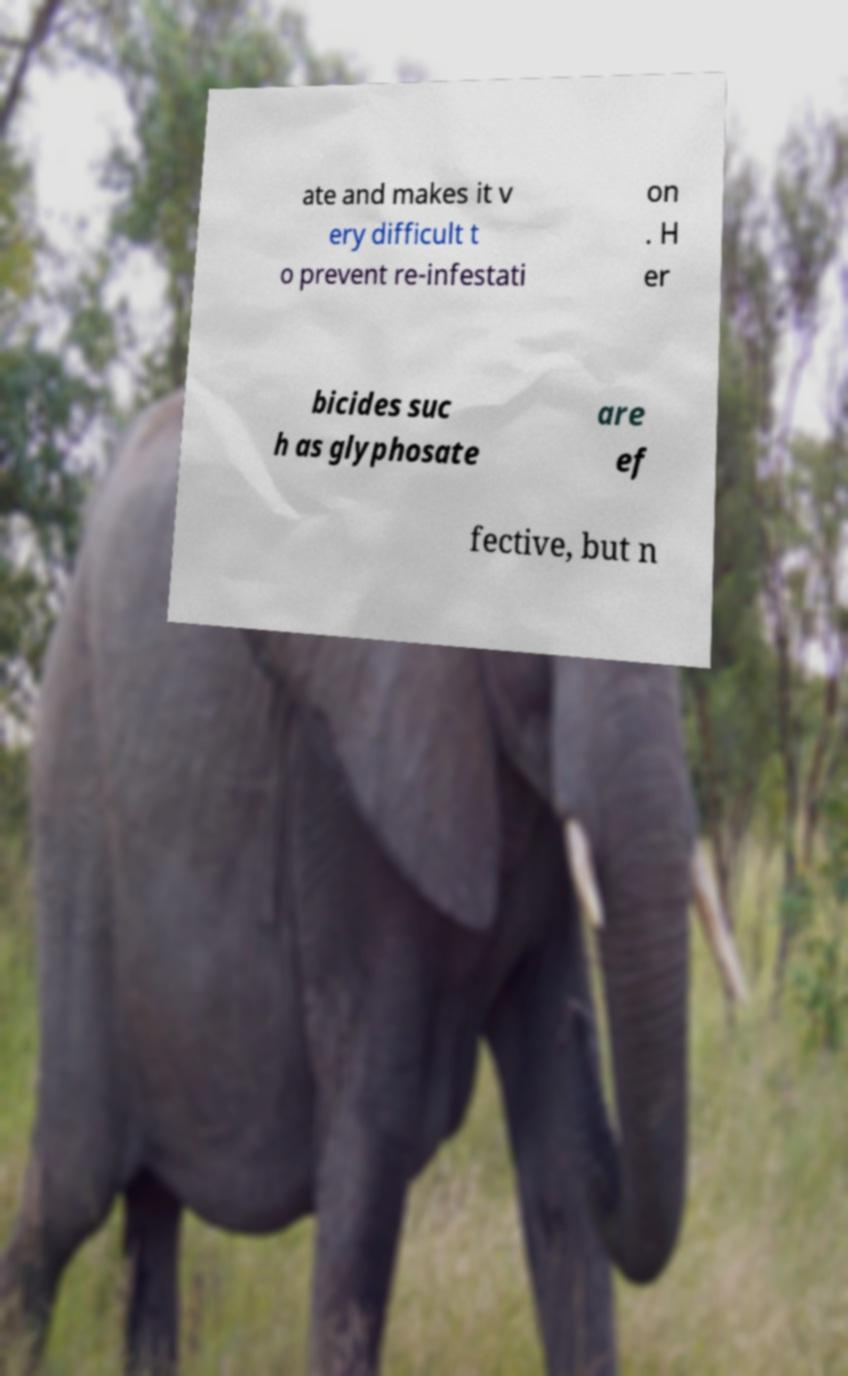Could you extract and type out the text from this image? ate and makes it v ery difficult t o prevent re-infestati on . H er bicides suc h as glyphosate are ef fective, but n 